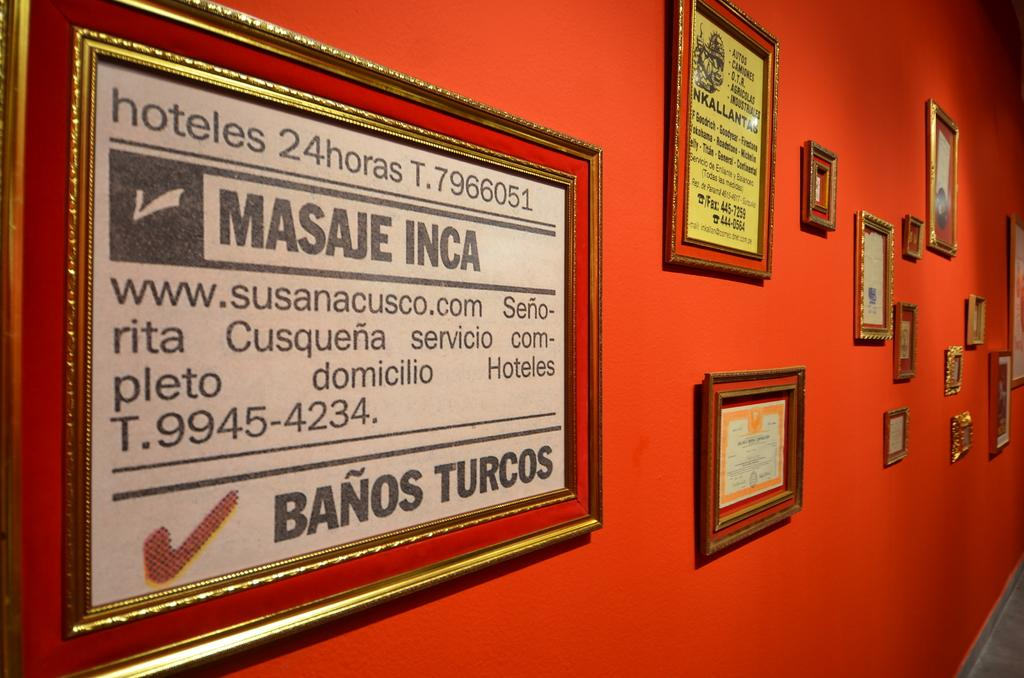<image>
Summarize the visual content of the image. Framed sign on an orange wall that says hoteles 24horas. 